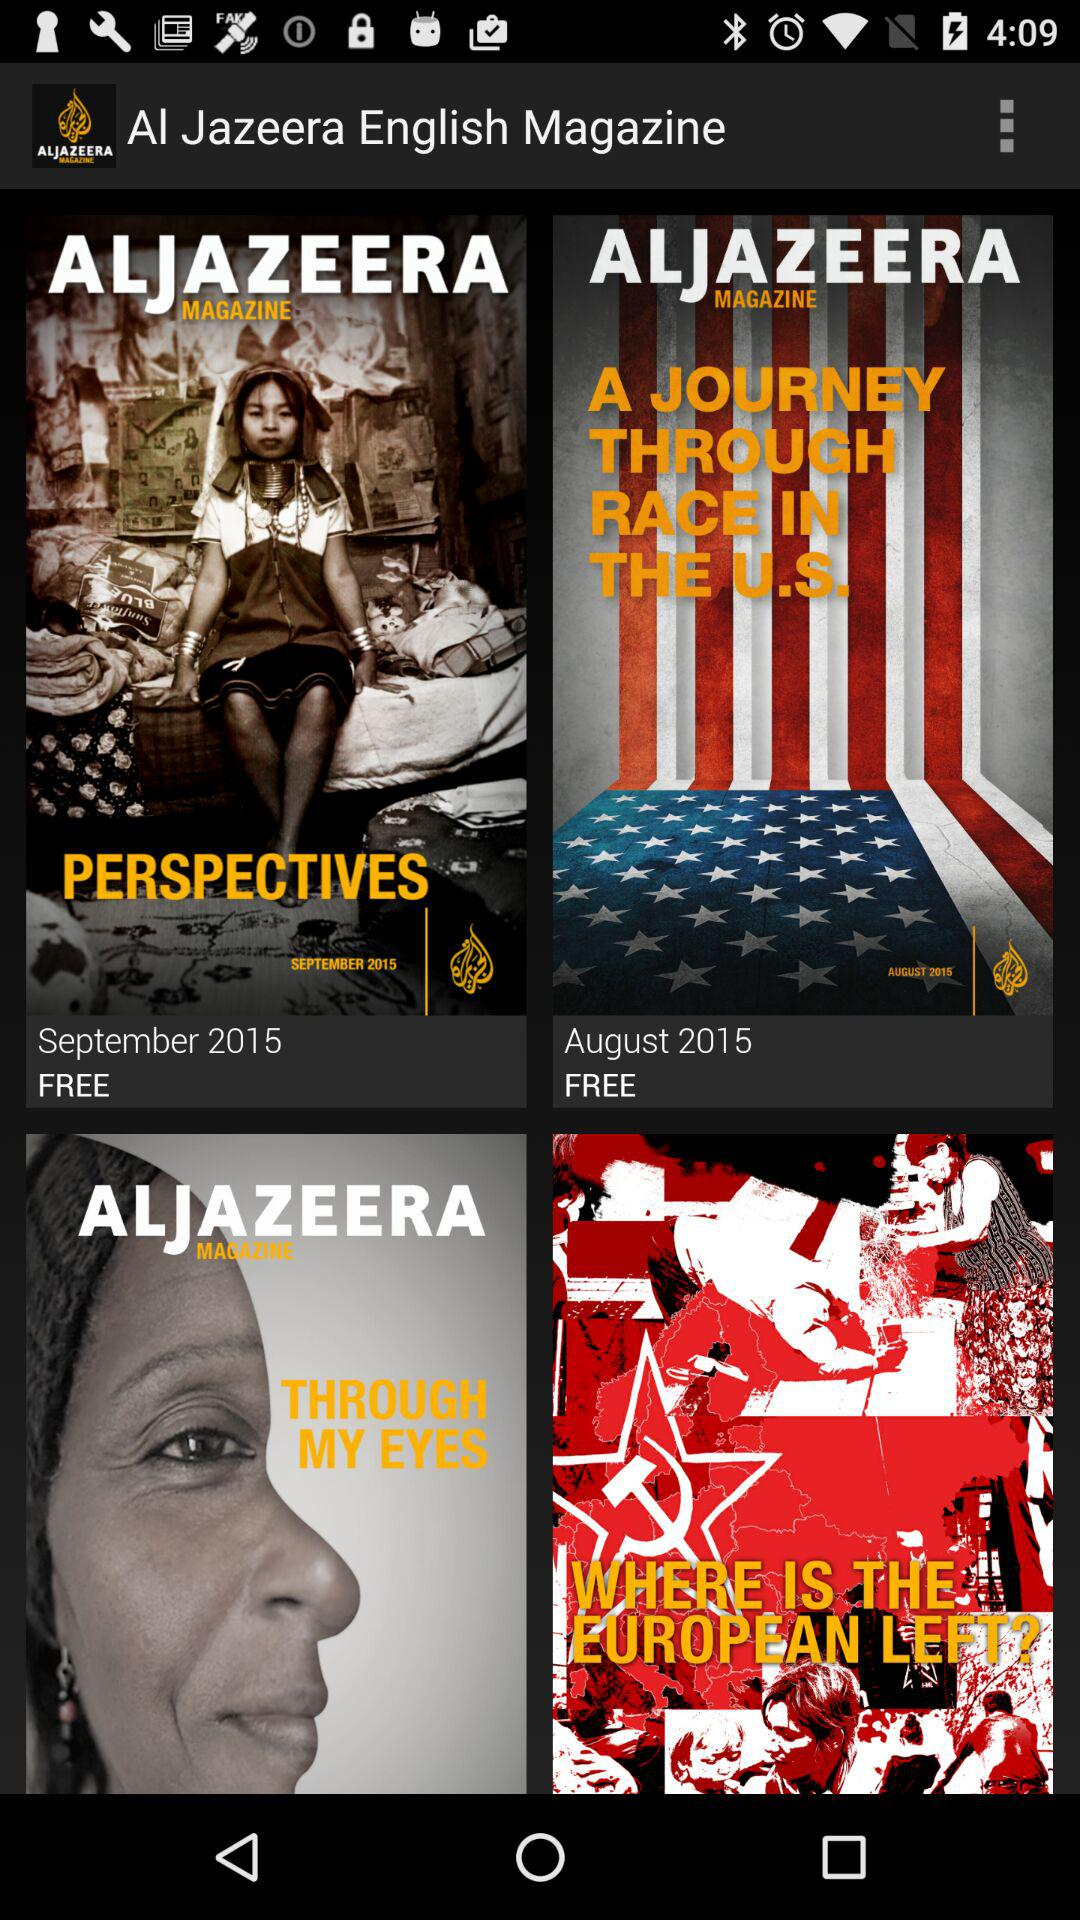What is the lead article of the magazine that was launched in August 2015? The lead article of the magazine that was launched in August 2015 is "A JOURNEY THROUGH RACE IN THE U.S.". 